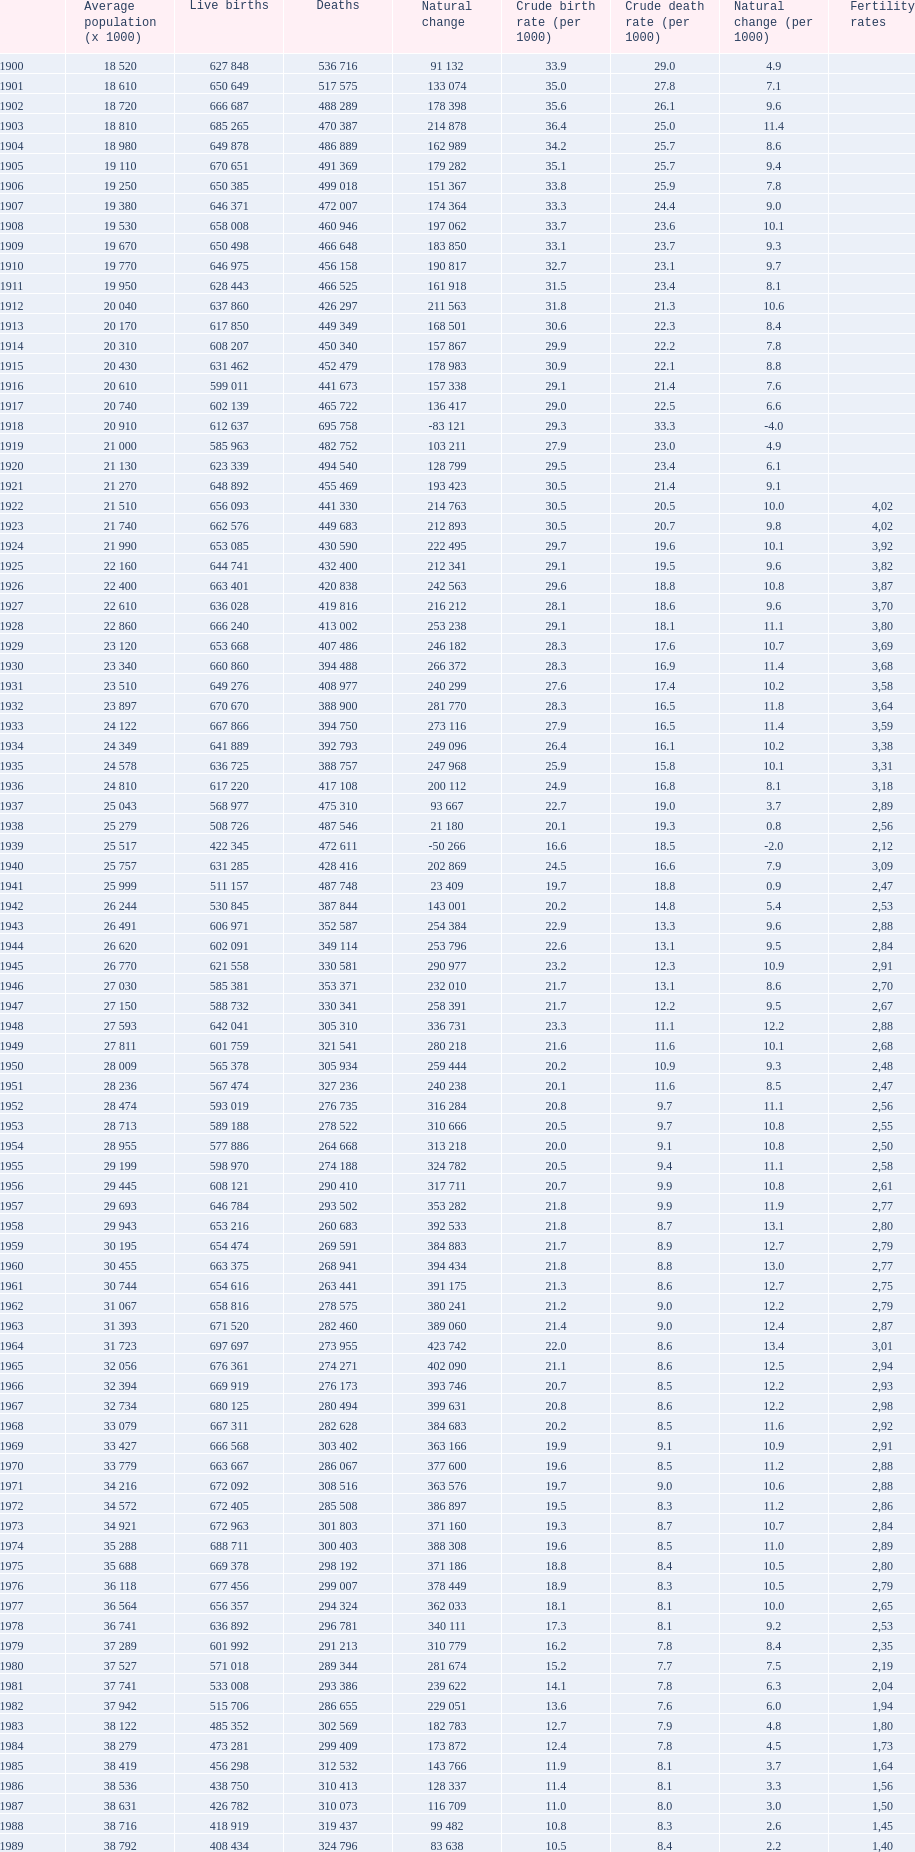In which year was the greatest difference between live births and deaths observed in spain? 1964. Could you parse the entire table as a dict? {'header': ['', 'Average population (x 1000)', 'Live births', 'Deaths', 'Natural change', 'Crude birth rate (per 1000)', 'Crude death rate (per 1000)', 'Natural change (per 1000)', 'Fertility rates'], 'rows': [['1900', '18 520', '627 848', '536 716', '91 132', '33.9', '29.0', '4.9', ''], ['1901', '18 610', '650 649', '517 575', '133 074', '35.0', '27.8', '7.1', ''], ['1902', '18 720', '666 687', '488 289', '178 398', '35.6', '26.1', '9.6', ''], ['1903', '18 810', '685 265', '470 387', '214 878', '36.4', '25.0', '11.4', ''], ['1904', '18 980', '649 878', '486 889', '162 989', '34.2', '25.7', '8.6', ''], ['1905', '19 110', '670 651', '491 369', '179 282', '35.1', '25.7', '9.4', ''], ['1906', '19 250', '650 385', '499 018', '151 367', '33.8', '25.9', '7.8', ''], ['1907', '19 380', '646 371', '472 007', '174 364', '33.3', '24.4', '9.0', ''], ['1908', '19 530', '658 008', '460 946', '197 062', '33.7', '23.6', '10.1', ''], ['1909', '19 670', '650 498', '466 648', '183 850', '33.1', '23.7', '9.3', ''], ['1910', '19 770', '646 975', '456 158', '190 817', '32.7', '23.1', '9.7', ''], ['1911', '19 950', '628 443', '466 525', '161 918', '31.5', '23.4', '8.1', ''], ['1912', '20 040', '637 860', '426 297', '211 563', '31.8', '21.3', '10.6', ''], ['1913', '20 170', '617 850', '449 349', '168 501', '30.6', '22.3', '8.4', ''], ['1914', '20 310', '608 207', '450 340', '157 867', '29.9', '22.2', '7.8', ''], ['1915', '20 430', '631 462', '452 479', '178 983', '30.9', '22.1', '8.8', ''], ['1916', '20 610', '599 011', '441 673', '157 338', '29.1', '21.4', '7.6', ''], ['1917', '20 740', '602 139', '465 722', '136 417', '29.0', '22.5', '6.6', ''], ['1918', '20 910', '612 637', '695 758', '-83 121', '29.3', '33.3', '-4.0', ''], ['1919', '21 000', '585 963', '482 752', '103 211', '27.9', '23.0', '4.9', ''], ['1920', '21 130', '623 339', '494 540', '128 799', '29.5', '23.4', '6.1', ''], ['1921', '21 270', '648 892', '455 469', '193 423', '30.5', '21.4', '9.1', ''], ['1922', '21 510', '656 093', '441 330', '214 763', '30.5', '20.5', '10.0', '4,02'], ['1923', '21 740', '662 576', '449 683', '212 893', '30.5', '20.7', '9.8', '4,02'], ['1924', '21 990', '653 085', '430 590', '222 495', '29.7', '19.6', '10.1', '3,92'], ['1925', '22 160', '644 741', '432 400', '212 341', '29.1', '19.5', '9.6', '3,82'], ['1926', '22 400', '663 401', '420 838', '242 563', '29.6', '18.8', '10.8', '3,87'], ['1927', '22 610', '636 028', '419 816', '216 212', '28.1', '18.6', '9.6', '3,70'], ['1928', '22 860', '666 240', '413 002', '253 238', '29.1', '18.1', '11.1', '3,80'], ['1929', '23 120', '653 668', '407 486', '246 182', '28.3', '17.6', '10.7', '3,69'], ['1930', '23 340', '660 860', '394 488', '266 372', '28.3', '16.9', '11.4', '3,68'], ['1931', '23 510', '649 276', '408 977', '240 299', '27.6', '17.4', '10.2', '3,58'], ['1932', '23 897', '670 670', '388 900', '281 770', '28.3', '16.5', '11.8', '3,64'], ['1933', '24 122', '667 866', '394 750', '273 116', '27.9', '16.5', '11.4', '3,59'], ['1934', '24 349', '641 889', '392 793', '249 096', '26.4', '16.1', '10.2', '3,38'], ['1935', '24 578', '636 725', '388 757', '247 968', '25.9', '15.8', '10.1', '3,31'], ['1936', '24 810', '617 220', '417 108', '200 112', '24.9', '16.8', '8.1', '3,18'], ['1937', '25 043', '568 977', '475 310', '93 667', '22.7', '19.0', '3.7', '2,89'], ['1938', '25 279', '508 726', '487 546', '21 180', '20.1', '19.3', '0.8', '2,56'], ['1939', '25 517', '422 345', '472 611', '-50 266', '16.6', '18.5', '-2.0', '2,12'], ['1940', '25 757', '631 285', '428 416', '202 869', '24.5', '16.6', '7.9', '3,09'], ['1941', '25 999', '511 157', '487 748', '23 409', '19.7', '18.8', '0.9', '2,47'], ['1942', '26 244', '530 845', '387 844', '143 001', '20.2', '14.8', '5.4', '2,53'], ['1943', '26 491', '606 971', '352 587', '254 384', '22.9', '13.3', '9.6', '2,88'], ['1944', '26 620', '602 091', '349 114', '253 796', '22.6', '13.1', '9.5', '2,84'], ['1945', '26 770', '621 558', '330 581', '290 977', '23.2', '12.3', '10.9', '2,91'], ['1946', '27 030', '585 381', '353 371', '232 010', '21.7', '13.1', '8.6', '2,70'], ['1947', '27 150', '588 732', '330 341', '258 391', '21.7', '12.2', '9.5', '2,67'], ['1948', '27 593', '642 041', '305 310', '336 731', '23.3', '11.1', '12.2', '2,88'], ['1949', '27 811', '601 759', '321 541', '280 218', '21.6', '11.6', '10.1', '2,68'], ['1950', '28 009', '565 378', '305 934', '259 444', '20.2', '10.9', '9.3', '2,48'], ['1951', '28 236', '567 474', '327 236', '240 238', '20.1', '11.6', '8.5', '2,47'], ['1952', '28 474', '593 019', '276 735', '316 284', '20.8', '9.7', '11.1', '2,56'], ['1953', '28 713', '589 188', '278 522', '310 666', '20.5', '9.7', '10.8', '2,55'], ['1954', '28 955', '577 886', '264 668', '313 218', '20.0', '9.1', '10.8', '2,50'], ['1955', '29 199', '598 970', '274 188', '324 782', '20.5', '9.4', '11.1', '2,58'], ['1956', '29 445', '608 121', '290 410', '317 711', '20.7', '9.9', '10.8', '2,61'], ['1957', '29 693', '646 784', '293 502', '353 282', '21.8', '9.9', '11.9', '2,77'], ['1958', '29 943', '653 216', '260 683', '392 533', '21.8', '8.7', '13.1', '2,80'], ['1959', '30 195', '654 474', '269 591', '384 883', '21.7', '8.9', '12.7', '2,79'], ['1960', '30 455', '663 375', '268 941', '394 434', '21.8', '8.8', '13.0', '2,77'], ['1961', '30 744', '654 616', '263 441', '391 175', '21.3', '8.6', '12.7', '2,75'], ['1962', '31 067', '658 816', '278 575', '380 241', '21.2', '9.0', '12.2', '2,79'], ['1963', '31 393', '671 520', '282 460', '389 060', '21.4', '9.0', '12.4', '2,87'], ['1964', '31 723', '697 697', '273 955', '423 742', '22.0', '8.6', '13.4', '3,01'], ['1965', '32 056', '676 361', '274 271', '402 090', '21.1', '8.6', '12.5', '2,94'], ['1966', '32 394', '669 919', '276 173', '393 746', '20.7', '8.5', '12.2', '2,93'], ['1967', '32 734', '680 125', '280 494', '399 631', '20.8', '8.6', '12.2', '2,98'], ['1968', '33 079', '667 311', '282 628', '384 683', '20.2', '8.5', '11.6', '2,92'], ['1969', '33 427', '666 568', '303 402', '363 166', '19.9', '9.1', '10.9', '2,91'], ['1970', '33 779', '663 667', '286 067', '377 600', '19.6', '8.5', '11.2', '2,88'], ['1971', '34 216', '672 092', '308 516', '363 576', '19.7', '9.0', '10.6', '2,88'], ['1972', '34 572', '672 405', '285 508', '386 897', '19.5', '8.3', '11.2', '2,86'], ['1973', '34 921', '672 963', '301 803', '371 160', '19.3', '8.7', '10.7', '2,84'], ['1974', '35 288', '688 711', '300 403', '388 308', '19.6', '8.5', '11.0', '2,89'], ['1975', '35 688', '669 378', '298 192', '371 186', '18.8', '8.4', '10.5', '2,80'], ['1976', '36 118', '677 456', '299 007', '378 449', '18.9', '8.3', '10.5', '2,79'], ['1977', '36 564', '656 357', '294 324', '362 033', '18.1', '8.1', '10.0', '2,65'], ['1978', '36 741', '636 892', '296 781', '340 111', '17.3', '8.1', '9.2', '2,53'], ['1979', '37 289', '601 992', '291 213', '310 779', '16.2', '7.8', '8.4', '2,35'], ['1980', '37 527', '571 018', '289 344', '281 674', '15.2', '7.7', '7.5', '2,19'], ['1981', '37 741', '533 008', '293 386', '239 622', '14.1', '7.8', '6.3', '2,04'], ['1982', '37 942', '515 706', '286 655', '229 051', '13.6', '7.6', '6.0', '1,94'], ['1983', '38 122', '485 352', '302 569', '182 783', '12.7', '7.9', '4.8', '1,80'], ['1984', '38 279', '473 281', '299 409', '173 872', '12.4', '7.8', '4.5', '1,73'], ['1985', '38 419', '456 298', '312 532', '143 766', '11.9', '8.1', '3.7', '1,64'], ['1986', '38 536', '438 750', '310 413', '128 337', '11.4', '8.1', '3.3', '1,56'], ['1987', '38 631', '426 782', '310 073', '116 709', '11.0', '8.0', '3.0', '1,50'], ['1988', '38 716', '418 919', '319 437', '99 482', '10.8', '8.3', '2.6', '1,45'], ['1989', '38 792', '408 434', '324 796', '83 638', '10.5', '8.4', '2.2', '1,40'], ['1990', '38 851', '401 425', '333 142', '68 283', '10.3', '8.6', '1.8', '1,36'], ['1991', '38 940', '395 989', '337 691', '58 298', '10.2', '8.7', '1.5', '1,33'], ['1992', '39 068', '396 747', '331 515', '65 232', '10.2', '8.5', '1.7', '1,32'], ['1993', '39 190', '385 786', '339 661', '46 125', '9.8', '8.7', '1.2', '1,26'], ['1994', '39 295', '370 148', '338 242', '31 906', '9.4', '8.6', '0.8', '1,21'], ['1995', '39 387', '363 469', '346 227', '17 242', '9.2', '8.8', '0.4', '1,18'], ['1996', '39 478', '362 626', '351 449', '11 177', '9.2', '8.9', '0.3', '1,17'], ['1997', '39 582', '369 035', '349 521', '19 514', '9.3', '8.8', '0.5', '1,19'], ['1998', '39 721', '365 193', '360 511', '4 682', '9.2', '9.1', '0.1', '1,15'], ['1999', '39 927', '380 130', '371 102', '9 028', '9.5', '9.3', '0.2', '1,20'], ['2000', '40 264', '397 632', '360 391', '37 241', '9.9', '9.0', '0.9', '1,23'], ['2001', '40 476', '406 380', '360 131', '46 249', '10.0', '8.8', '1.1', '1,24'], ['2002', '41 035', '418 846', '368 618', '50 228', '10.1', '8.9', '1.2', '1,26'], ['2003', '41 827', '441 881', '384 828', '57 053', '10.5', '9.2', '1.4', '1,31'], ['2004', '42 547', '454 591', '371 934', '82 657', '10.6', '8.7', '1.9', '1,33'], ['2005', '43 296', '466 371', '387 355', '79 016', '10.7', '8.9', '1.8', '1,35'], ['2006', '44 009', '482 957', '371 478', '111 479', '10.9', '8.4', '2.5', '1,36'], ['2007', '44 784', '492 527', '385 361', '107 166', '10.9', '8.5', '2.4', '1,40'], ['2008', '45 668', '518 503', '384 198', '134 305', '11.4', '8.4', '3.0', '1,46'], ['2009', '46 239', '493 717', '383 209', '110 508', '10.7', '8.2', '2.5', '1,39'], ['2010', '46 486', '485 252', '380 234', '105 218', '10.5', '8.2', '2.3', '1.38'], ['2011', '46 667', '470 553', '386 017', '84 536', '10.2', '8.4', '1.8', '1.34'], ['2012', '46 818', '454 648', '402 950', '51 698', '9.7', '8.6', '1.1', '1.32'], ['2013', '', '', '', '', '', '', '', '1.29']]} 